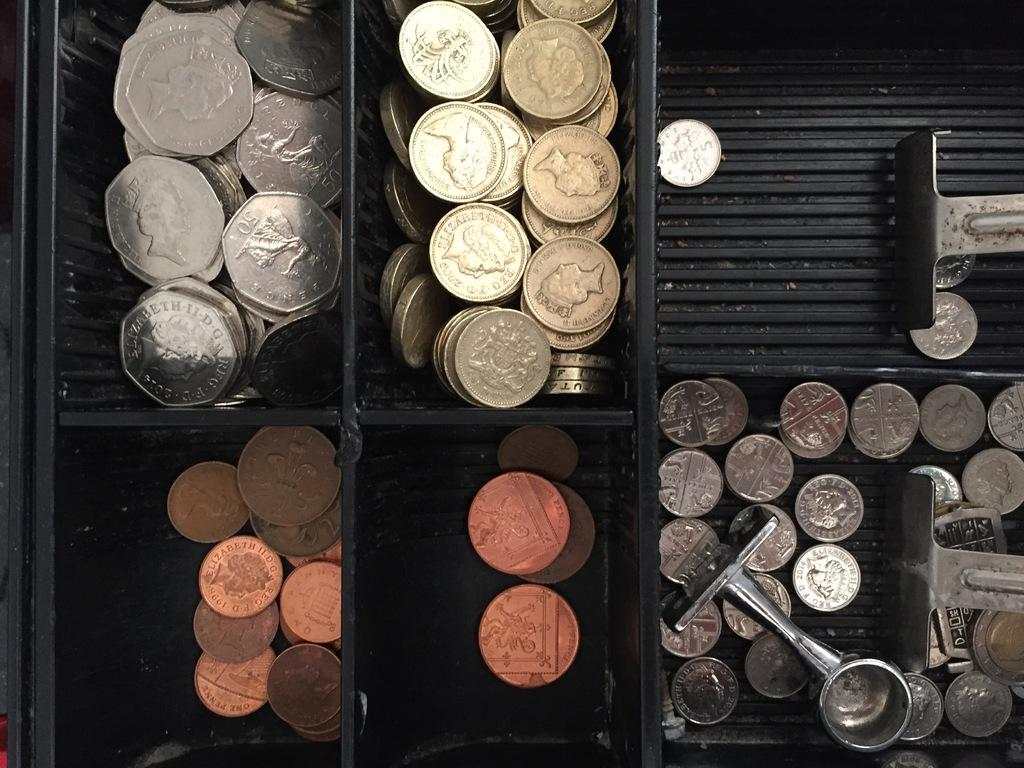<image>
Share a concise interpretation of the image provided. A coin near a silver object has the year 2014 on it and is surrounded by other coins. 